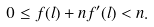<formula> <loc_0><loc_0><loc_500><loc_500>0 \leq f ( l ) + n f ^ { \prime } ( l ) < n .</formula> 